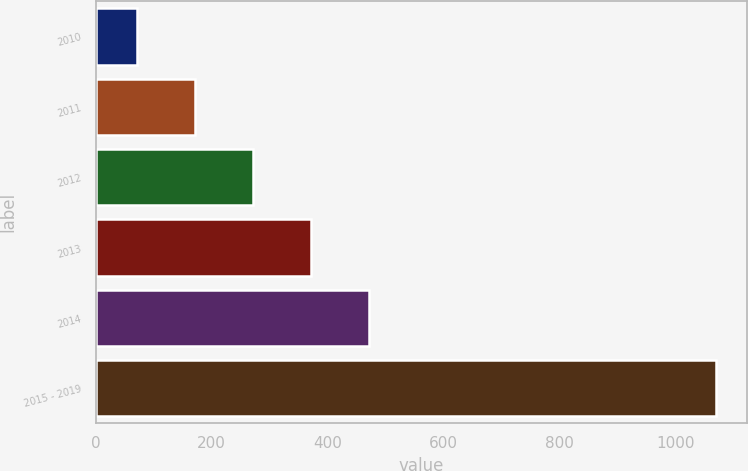Convert chart to OTSL. <chart><loc_0><loc_0><loc_500><loc_500><bar_chart><fcel>2010<fcel>2011<fcel>2012<fcel>2013<fcel>2014<fcel>2015 - 2019<nl><fcel>71<fcel>171<fcel>271<fcel>371<fcel>471<fcel>1071<nl></chart> 